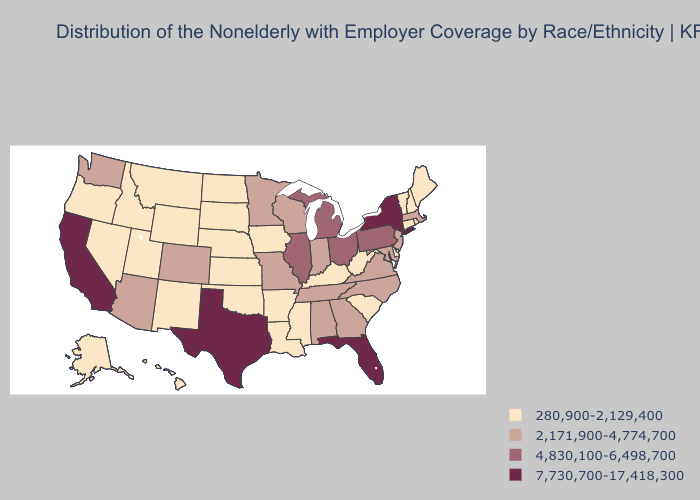Is the legend a continuous bar?
Write a very short answer. No. Does Illinois have the same value as Arizona?
Short answer required. No. Among the states that border Missouri , does Oklahoma have the highest value?
Short answer required. No. What is the lowest value in the USA?
Give a very brief answer. 280,900-2,129,400. Is the legend a continuous bar?
Short answer required. No. What is the highest value in the USA?
Write a very short answer. 7,730,700-17,418,300. Name the states that have a value in the range 2,171,900-4,774,700?
Short answer required. Alabama, Arizona, Colorado, Georgia, Indiana, Maryland, Massachusetts, Minnesota, Missouri, New Jersey, North Carolina, Tennessee, Virginia, Washington, Wisconsin. How many symbols are there in the legend?
Short answer required. 4. What is the value of South Dakota?
Give a very brief answer. 280,900-2,129,400. Does New Jersey have the lowest value in the USA?
Keep it brief. No. Does Maryland have a higher value than Florida?
Write a very short answer. No. Name the states that have a value in the range 4,830,100-6,498,700?
Write a very short answer. Illinois, Michigan, Ohio, Pennsylvania. Name the states that have a value in the range 280,900-2,129,400?
Write a very short answer. Alaska, Arkansas, Connecticut, Delaware, Hawaii, Idaho, Iowa, Kansas, Kentucky, Louisiana, Maine, Mississippi, Montana, Nebraska, Nevada, New Hampshire, New Mexico, North Dakota, Oklahoma, Oregon, Rhode Island, South Carolina, South Dakota, Utah, Vermont, West Virginia, Wyoming. Which states have the highest value in the USA?
Give a very brief answer. California, Florida, New York, Texas. What is the lowest value in states that border Missouri?
Be succinct. 280,900-2,129,400. 